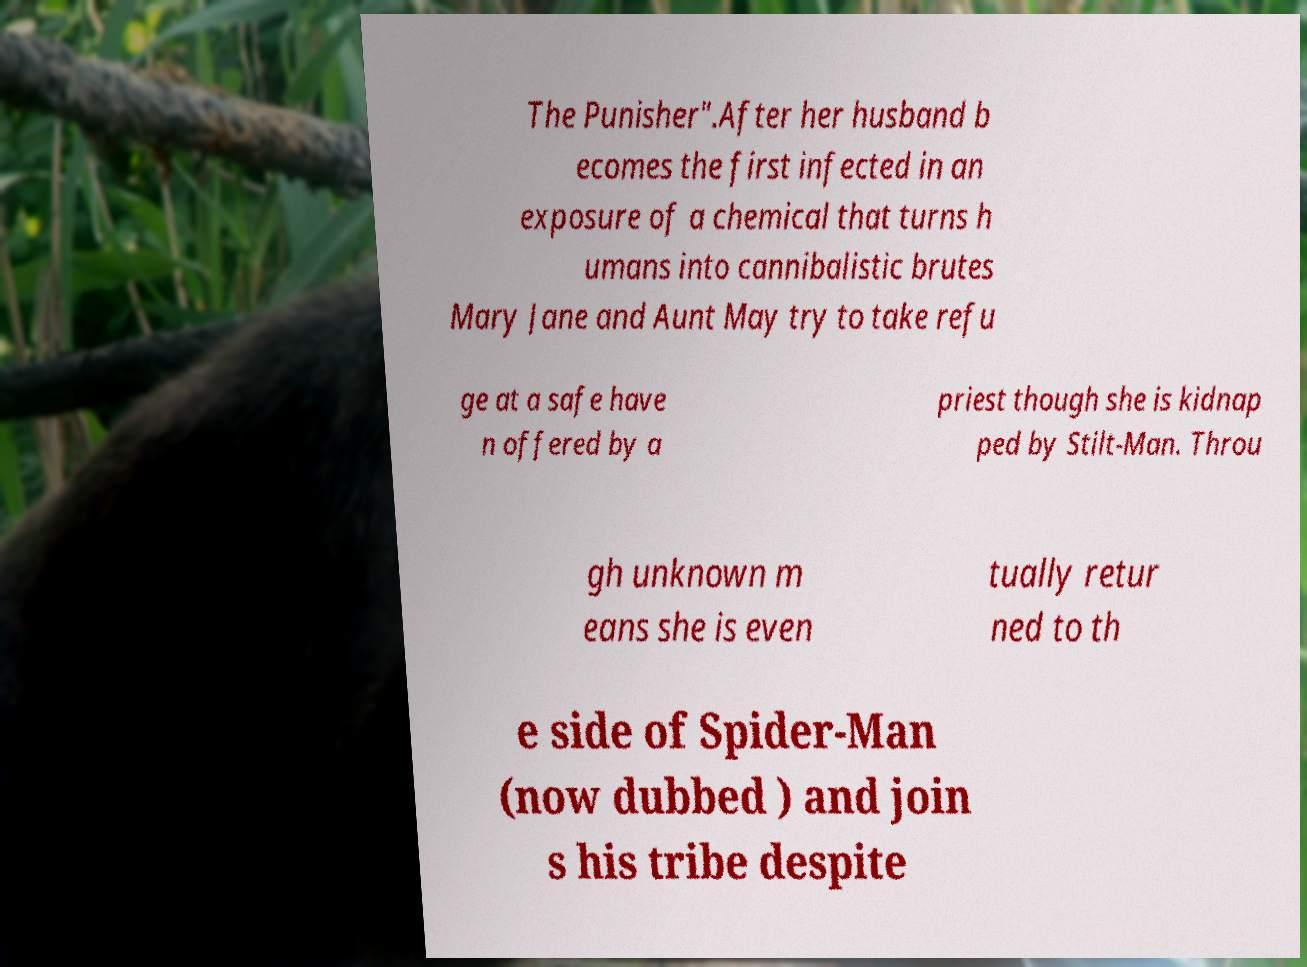I need the written content from this picture converted into text. Can you do that? The Punisher".After her husband b ecomes the first infected in an exposure of a chemical that turns h umans into cannibalistic brutes Mary Jane and Aunt May try to take refu ge at a safe have n offered by a priest though she is kidnap ped by Stilt-Man. Throu gh unknown m eans she is even tually retur ned to th e side of Spider-Man (now dubbed ) and join s his tribe despite 